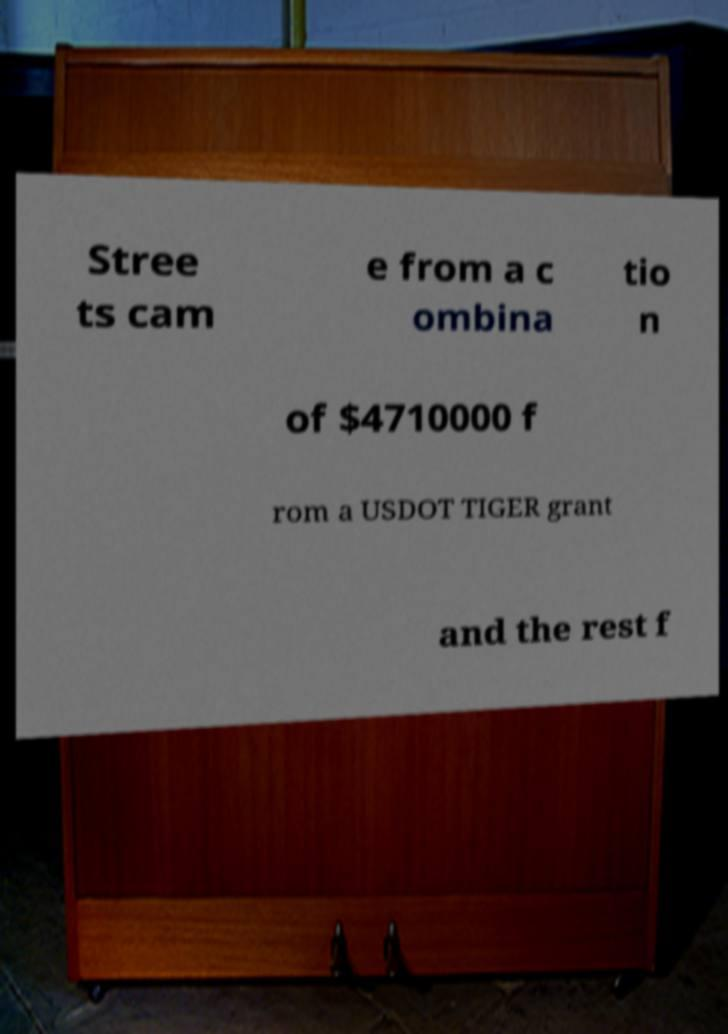Please identify and transcribe the text found in this image. Stree ts cam e from a c ombina tio n of $4710000 f rom a USDOT TIGER grant and the rest f 